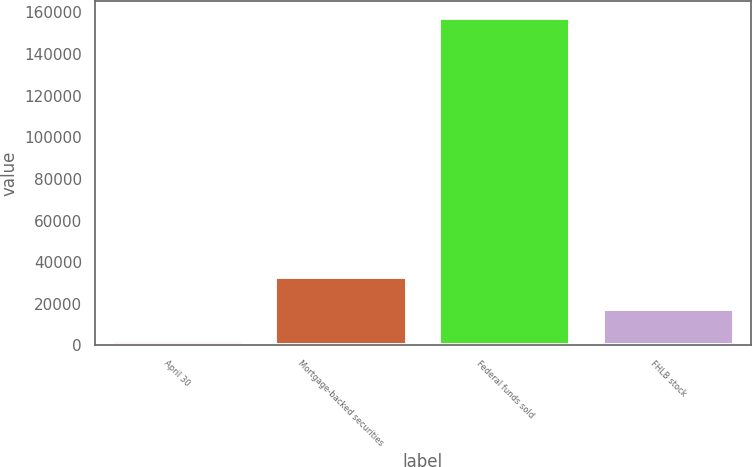Convert chart to OTSL. <chart><loc_0><loc_0><loc_500><loc_500><bar_chart><fcel>April 30<fcel>Mortgage-backed securities<fcel>Federal funds sold<fcel>FHLB stock<nl><fcel>2009<fcel>33072.4<fcel>157326<fcel>17540.7<nl></chart> 